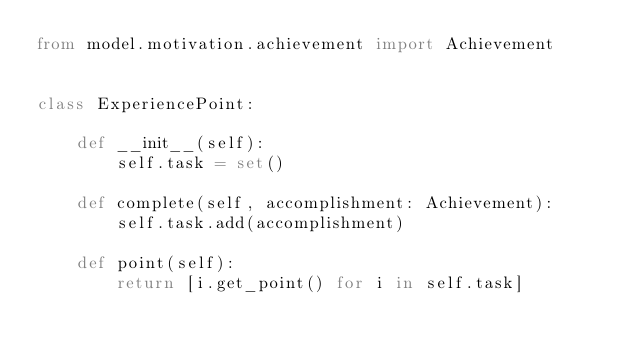<code> <loc_0><loc_0><loc_500><loc_500><_Python_>from model.motivation.achievement import Achievement


class ExperiencePoint:

    def __init__(self):
        self.task = set()

    def complete(self, accomplishment: Achievement):
        self.task.add(accomplishment)

    def point(self):
        return [i.get_point() for i in self.task]
</code> 